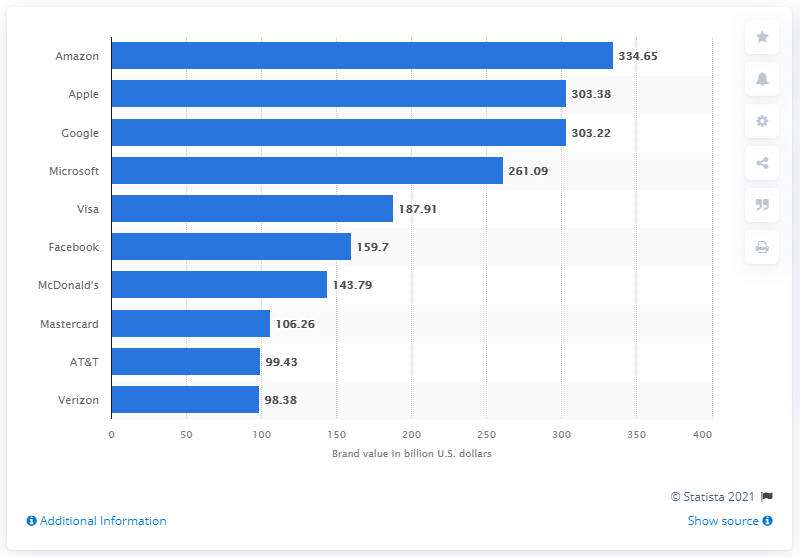Identify some key points in this picture. According to reliable sources, Google is the third most valuable brand in the United States. In 2020, Google's value in dollars in the United States was estimated to be approximately 303.38. Visa is the most valuable global brand, according to the latest rankings. 